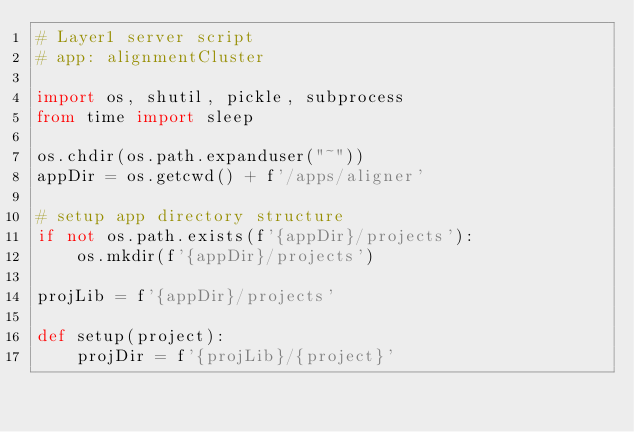Convert code to text. <code><loc_0><loc_0><loc_500><loc_500><_Python_># Layer1 server script
# app: alignmentCluster

import os, shutil, pickle, subprocess
from time import sleep

os.chdir(os.path.expanduser("~"))
appDir = os.getcwd() + f'/apps/aligner'

# setup app directory structure
if not os.path.exists(f'{appDir}/projects'):
    os.mkdir(f'{appDir}/projects')

projLib = f'{appDir}/projects'

def setup(project):
    projDir = f'{projLib}/{project}'</code> 